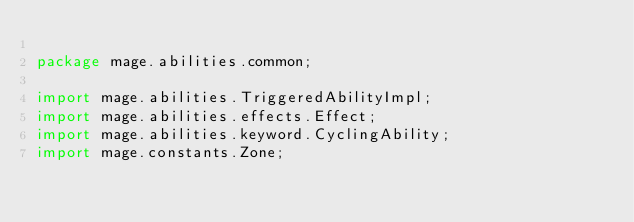<code> <loc_0><loc_0><loc_500><loc_500><_Java_>
package mage.abilities.common;

import mage.abilities.TriggeredAbilityImpl;
import mage.abilities.effects.Effect;
import mage.abilities.keyword.CyclingAbility;
import mage.constants.Zone;</code> 